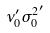Convert formula to latex. <formula><loc_0><loc_0><loc_500><loc_500>\nu _ { 0 } ^ { \prime } { \sigma _ { 0 } ^ { 2 } } ^ { \prime }</formula> 